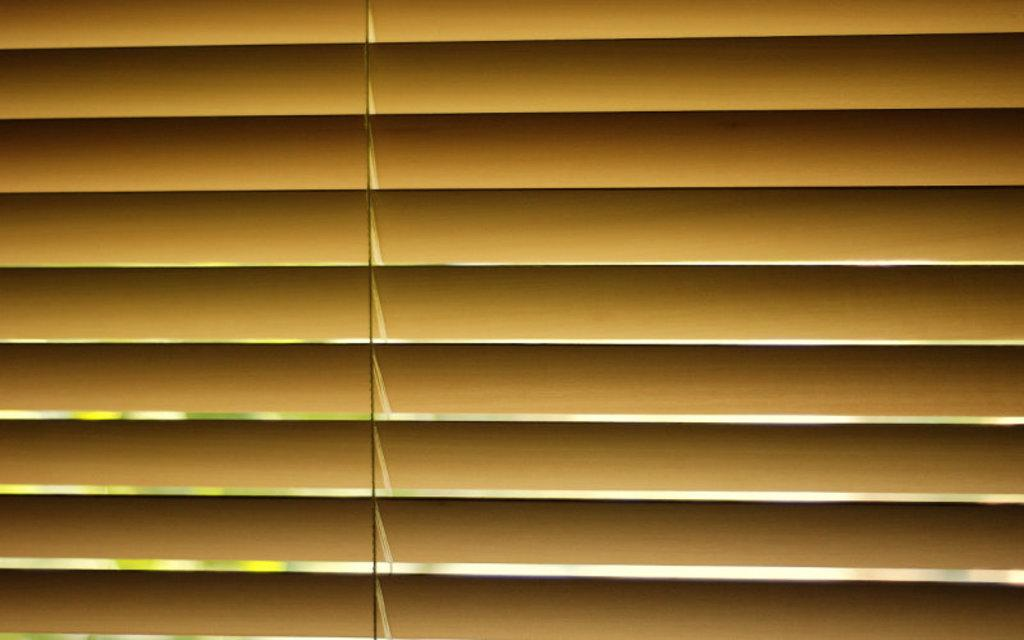What is present in the image related to window coverings? There is a window blind in the image. What type of thread is being used to sew the stem of the spoon in the image? There is no spoon or stem present in the image, and therefore no thread or sewing activity can be observed. 